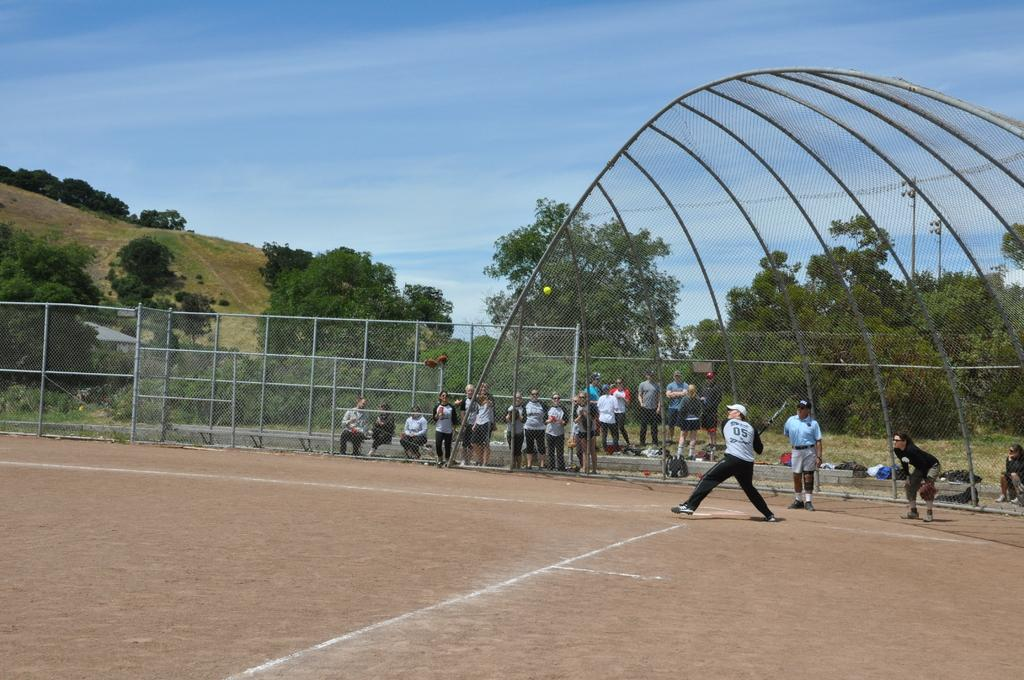<image>
Summarize the visual content of the image. The batter on the field has the number 05 written on his shirt. 